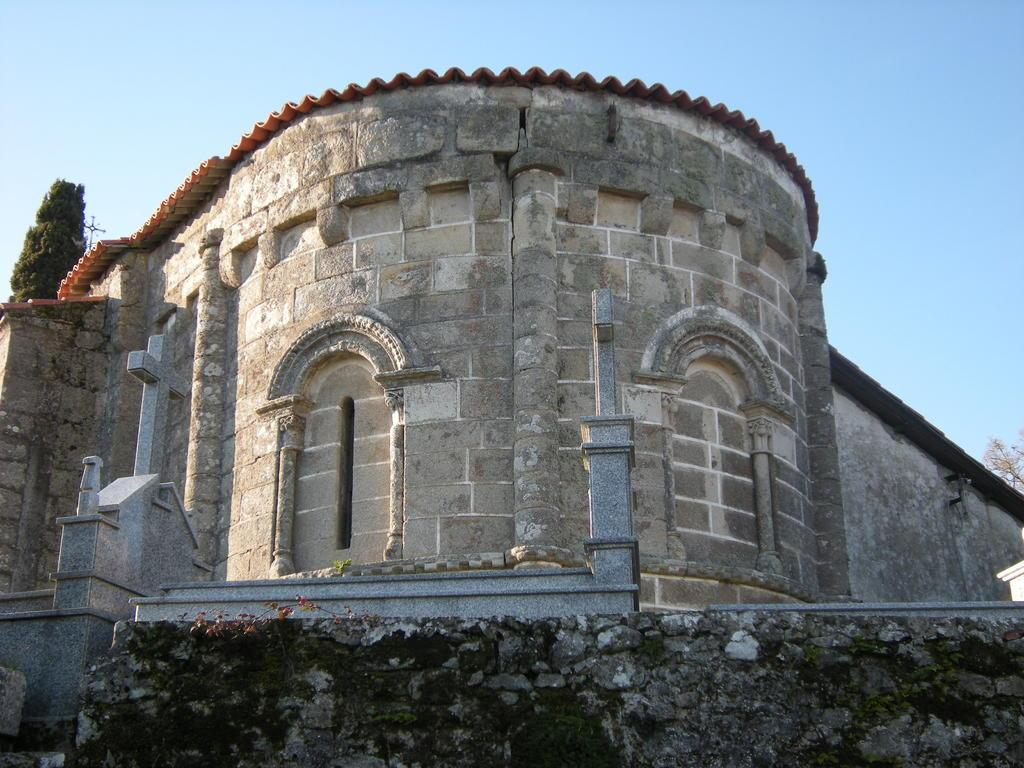What type of structure is visible in the image? There is a building in the image. What is located in front of the building? There is a wall in front of the building. What can be seen in the background of the image? There are trees and the sky visible in the background of the image. Can you see a kitten playing on the hill in the image? There is no hill or kitten present in the image. 